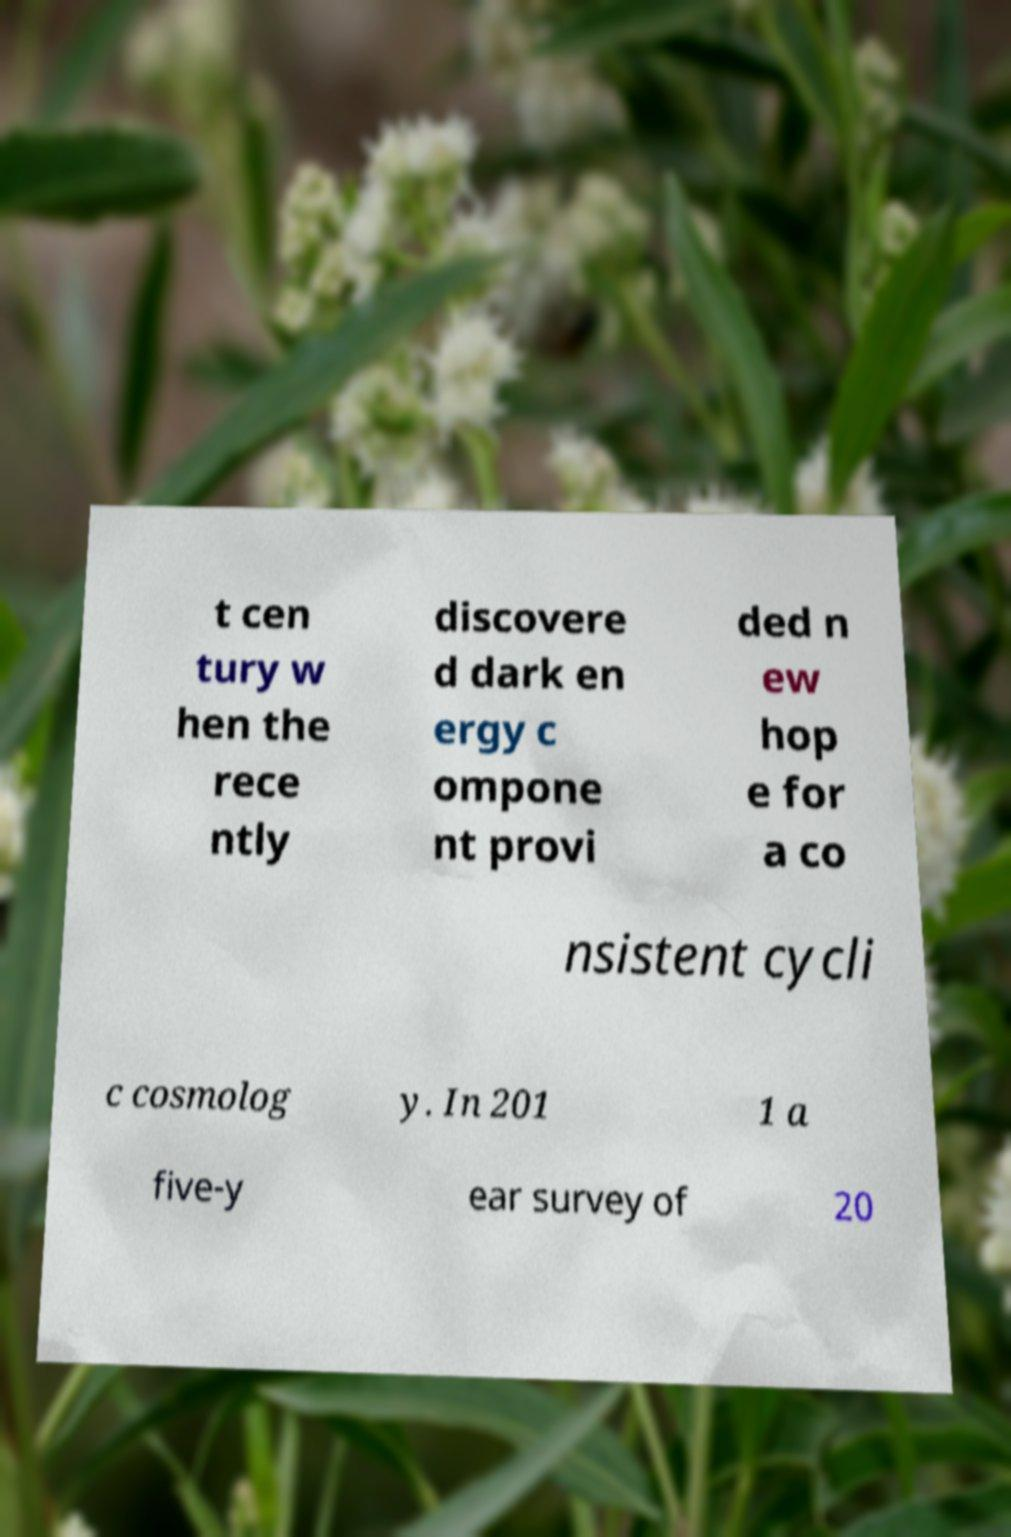Please read and relay the text visible in this image. What does it say? t cen tury w hen the rece ntly discovere d dark en ergy c ompone nt provi ded n ew hop e for a co nsistent cycli c cosmolog y. In 201 1 a five-y ear survey of 20 